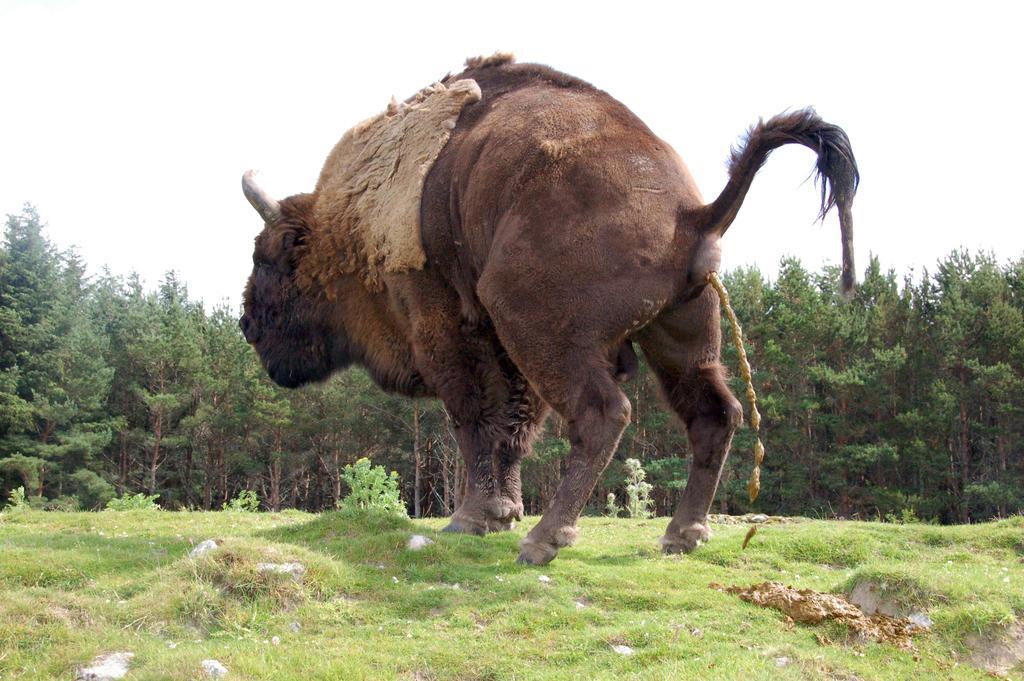Can you describe this image briefly? This brown color animal is highlighted in this picture. Far there are number of trees. Grass is in green color. Sky is in white color. 